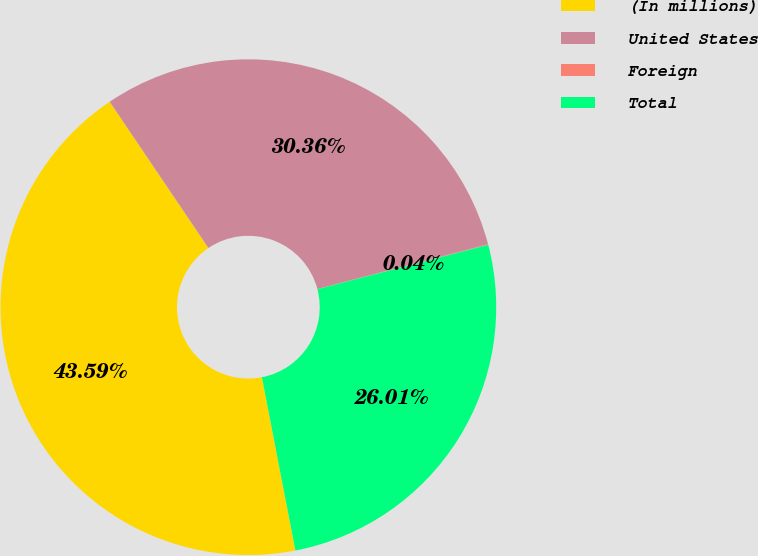<chart> <loc_0><loc_0><loc_500><loc_500><pie_chart><fcel>(In millions)<fcel>United States<fcel>Foreign<fcel>Total<nl><fcel>43.59%<fcel>30.36%<fcel>0.04%<fcel>26.01%<nl></chart> 